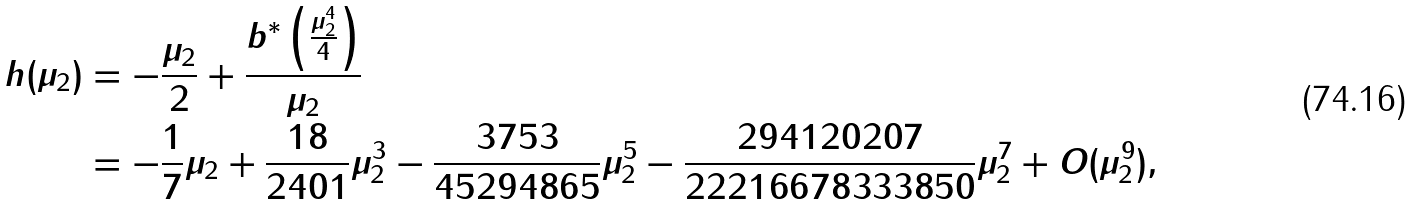Convert formula to latex. <formula><loc_0><loc_0><loc_500><loc_500>h ( \mu _ { 2 } ) & = - \frac { \mu _ { 2 } } 2 + \frac { b ^ { * } \left ( \frac { \mu _ { 2 } ^ { 4 } } 4 \right ) } { \mu _ { 2 } } \\ & = - \frac { 1 } { 7 } \mu _ { 2 } + \frac { 1 8 } { 2 4 0 1 } \mu _ { 2 } ^ { 3 } - \frac { 3 7 5 3 } { 4 5 2 9 4 8 6 5 } \mu _ { 2 } ^ { 5 } - \frac { 2 9 4 1 2 0 2 0 7 } { 2 2 2 1 6 6 7 8 3 3 3 8 5 0 } \mu _ { 2 } ^ { 7 } + O ( \mu _ { 2 } ^ { 9 } ) ,</formula> 